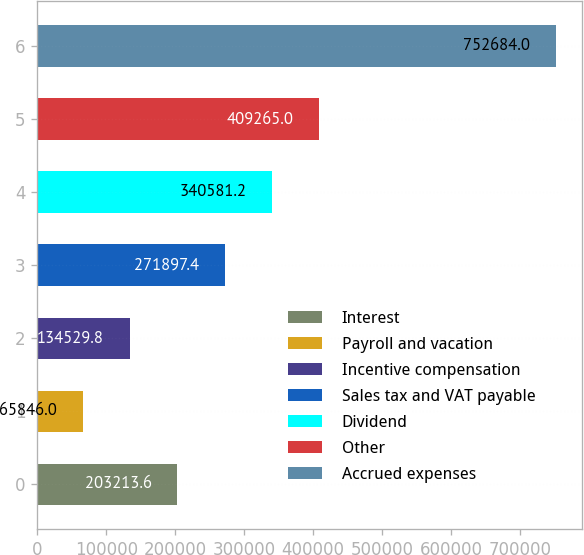<chart> <loc_0><loc_0><loc_500><loc_500><bar_chart><fcel>Interest<fcel>Payroll and vacation<fcel>Incentive compensation<fcel>Sales tax and VAT payable<fcel>Dividend<fcel>Other<fcel>Accrued expenses<nl><fcel>203214<fcel>65846<fcel>134530<fcel>271897<fcel>340581<fcel>409265<fcel>752684<nl></chart> 